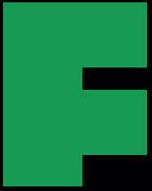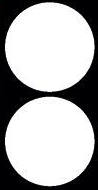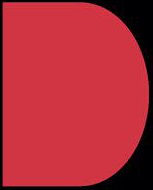What text appears in these images from left to right, separated by a semicolon? F; :; D 